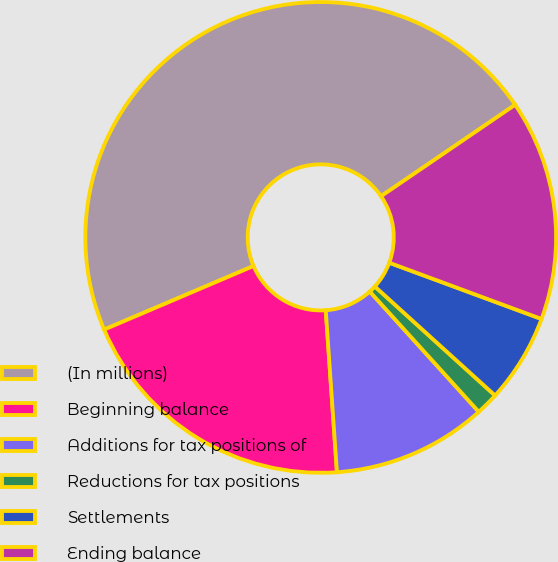<chart> <loc_0><loc_0><loc_500><loc_500><pie_chart><fcel>(In millions)<fcel>Beginning balance<fcel>Additions for tax positions of<fcel>Reductions for tax positions<fcel>Settlements<fcel>Ending balance<nl><fcel>46.88%<fcel>19.69%<fcel>10.62%<fcel>1.56%<fcel>6.09%<fcel>15.16%<nl></chart> 